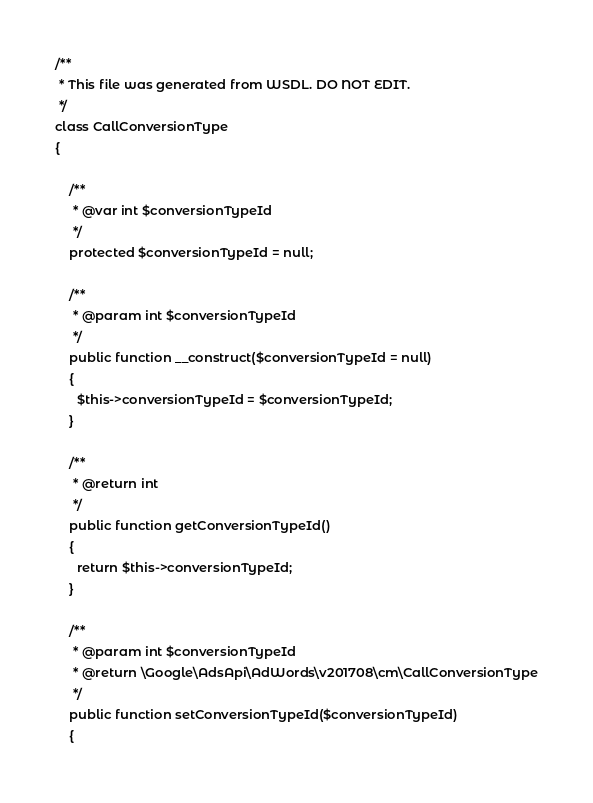<code> <loc_0><loc_0><loc_500><loc_500><_PHP_>

/**
 * This file was generated from WSDL. DO NOT EDIT.
 */
class CallConversionType
{

    /**
     * @var int $conversionTypeId
     */
    protected $conversionTypeId = null;

    /**
     * @param int $conversionTypeId
     */
    public function __construct($conversionTypeId = null)
    {
      $this->conversionTypeId = $conversionTypeId;
    }

    /**
     * @return int
     */
    public function getConversionTypeId()
    {
      return $this->conversionTypeId;
    }

    /**
     * @param int $conversionTypeId
     * @return \Google\AdsApi\AdWords\v201708\cm\CallConversionType
     */
    public function setConversionTypeId($conversionTypeId)
    {</code> 